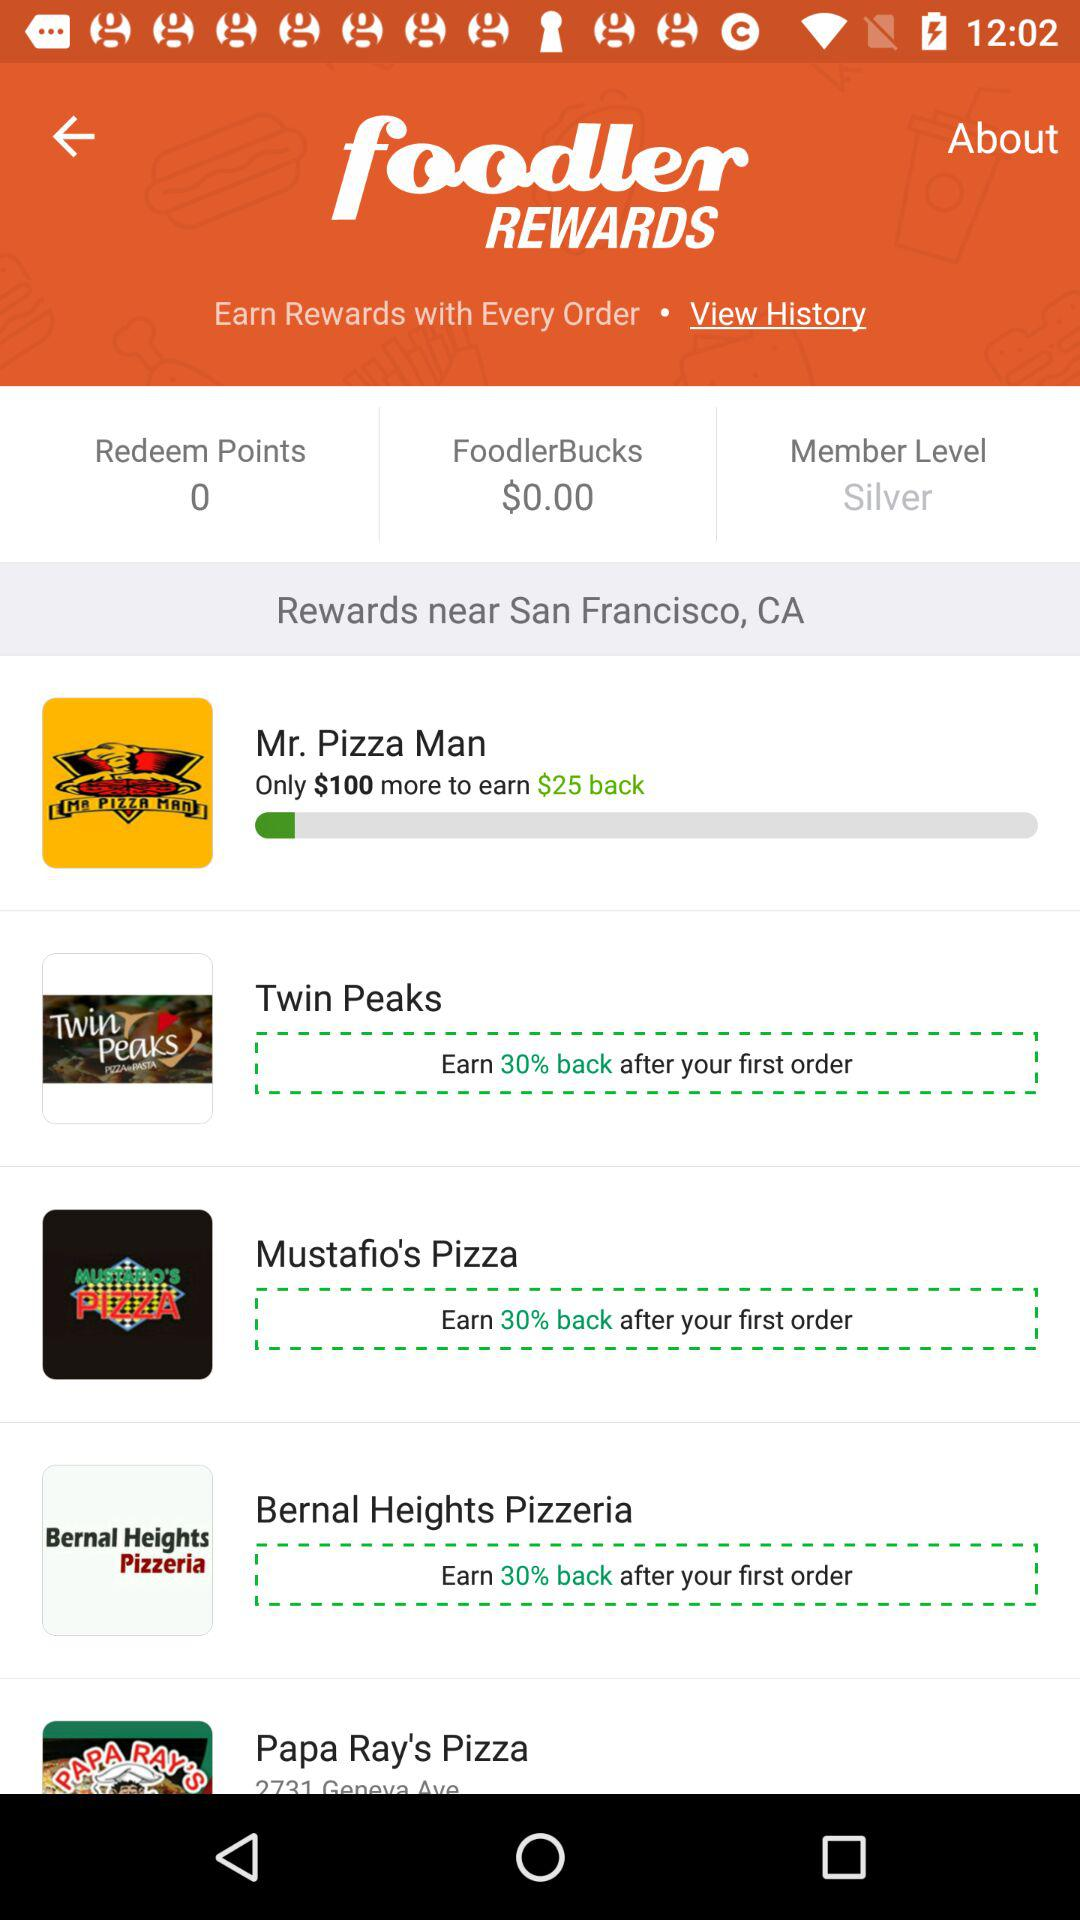What is the mentioned location? The mentioned location is San Francisco, CA. 